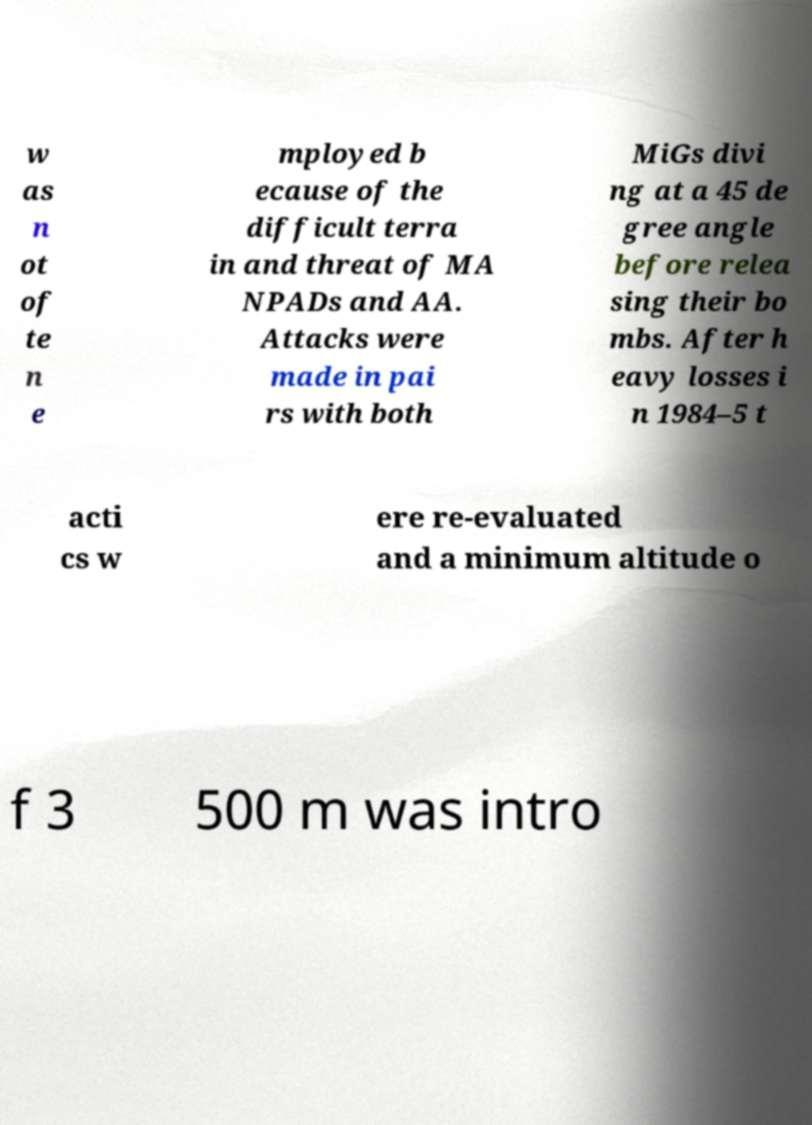I need the written content from this picture converted into text. Can you do that? w as n ot of te n e mployed b ecause of the difficult terra in and threat of MA NPADs and AA. Attacks were made in pai rs with both MiGs divi ng at a 45 de gree angle before relea sing their bo mbs. After h eavy losses i n 1984–5 t acti cs w ere re-evaluated and a minimum altitude o f 3 500 m was intro 